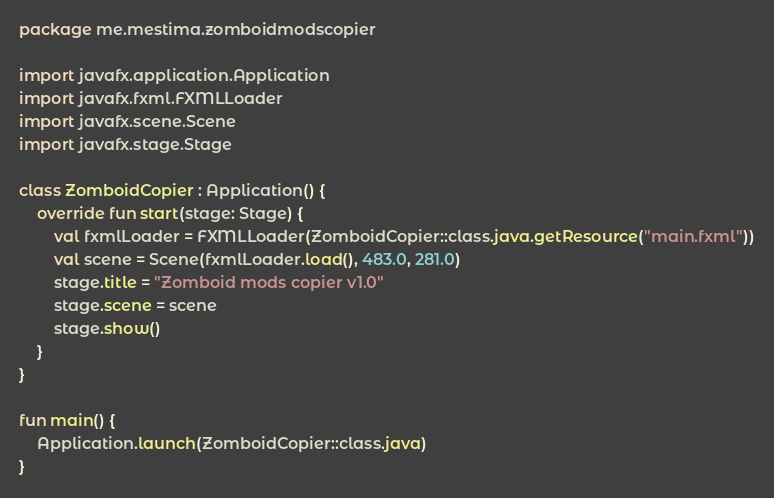Convert code to text. <code><loc_0><loc_0><loc_500><loc_500><_Kotlin_>package me.mestima.zomboidmodscopier

import javafx.application.Application
import javafx.fxml.FXMLLoader
import javafx.scene.Scene
import javafx.stage.Stage

class ZomboidCopier : Application() {
    override fun start(stage: Stage) {
        val fxmlLoader = FXMLLoader(ZomboidCopier::class.java.getResource("main.fxml"))
        val scene = Scene(fxmlLoader.load(), 483.0, 281.0)
        stage.title = "Zomboid mods copier v1.0"
        stage.scene = scene
        stage.show()
    }
}

fun main() {
    Application.launch(ZomboidCopier::class.java)
}</code> 